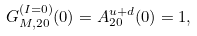<formula> <loc_0><loc_0><loc_500><loc_500>G _ { M , 2 0 } ^ { ( I = 0 ) } ( 0 ) = A _ { 2 0 } ^ { u + d } ( 0 ) = 1 ,</formula> 